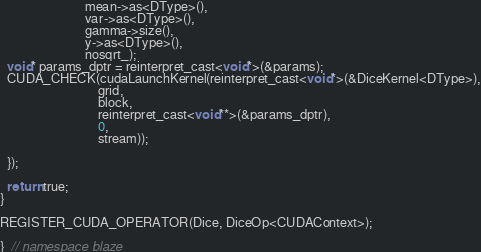Convert code to text. <code><loc_0><loc_0><loc_500><loc_500><_Cuda_>                          mean->as<DType>(),
                          var->as<DType>(),
                          gamma->size(),
                          y->as<DType>(),
                          nosqrt_);
  void* params_dptr = reinterpret_cast<void*>(&params);
  CUDA_CHECK(cudaLaunchKernel(reinterpret_cast<void*>(&DiceKernel<DType>),
                              grid,
                              block,
                              reinterpret_cast<void**>(&params_dptr),
                              0,
                              stream));

  });
  
  return true;
}

REGISTER_CUDA_OPERATOR(Dice, DiceOp<CUDAContext>);

}  // namespace blaze
</code> 